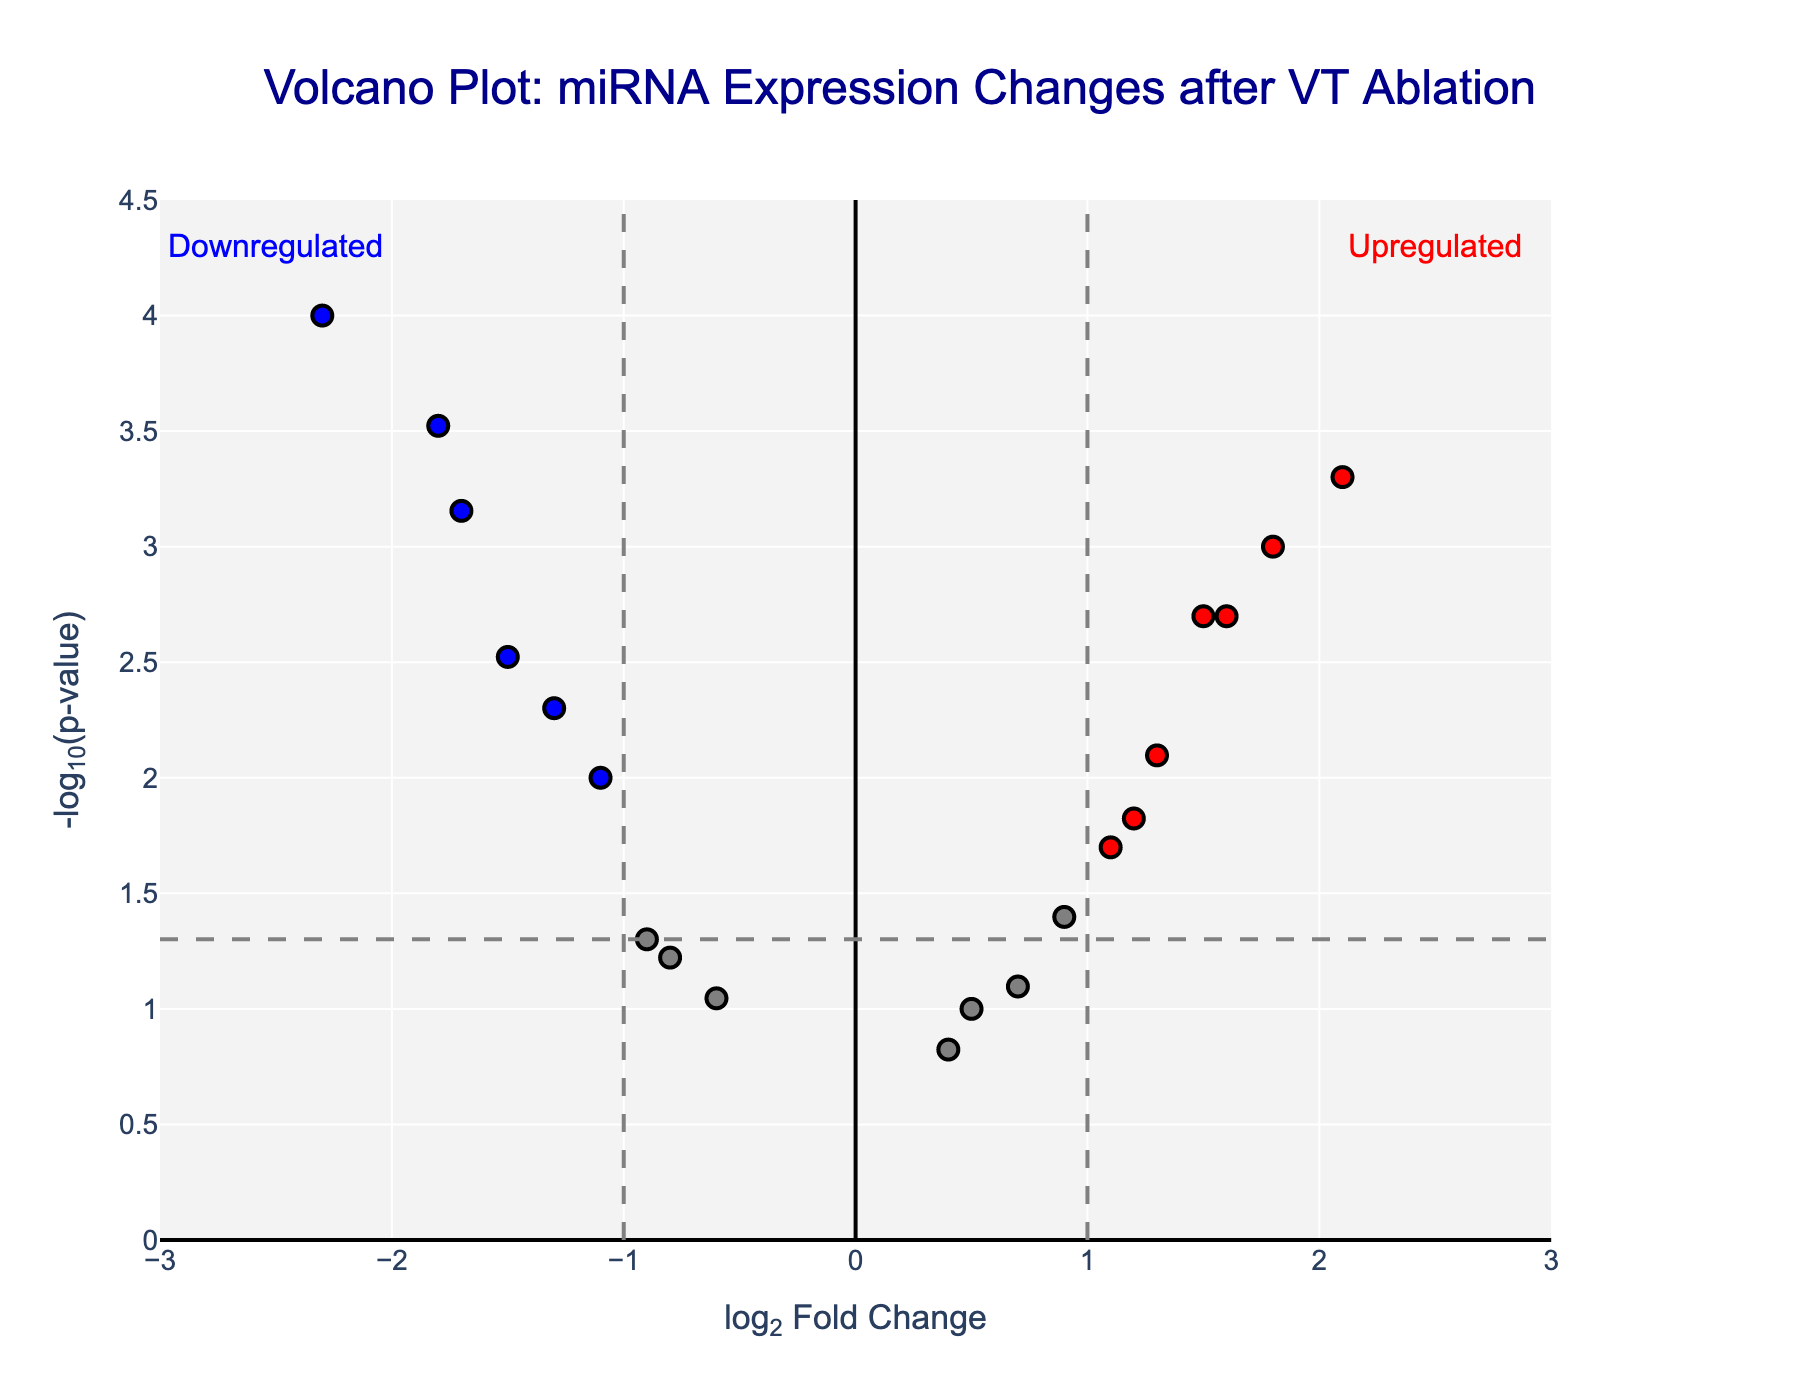Which miRNA has the highest log2 fold change? The highest log2 fold change can be identified by finding the data point furthest to the right of the x-axis. Here, miR-21 has the highest log2 fold change.
Answer: miR-21 Which miRNA has the lowest p-value? The lowest p-value can be identified by finding the data point highest on the y-axis, as p-value is represented on a log scale (-log10). miR-1 has the highest -log10(p-value).
Answer: miR-1 How many miRNAs are significantly upregulated (log2 fold change > 1 and p-value < 0.05)? To count the number of significantly upregulated miRNAs, look for data points that are colored red and are above the horizontal threshold line at -log10(0.05). There are 4 such miRNAs: miR-21, miR-208a, miR-150, and miR-155.
Answer: 4 How many miRNAs are significantly downregulated (log2 fold change < -1 and p-value < 0.05)? To count the number of significantly downregulated miRNAs, look for data points that are colored blue and are above the horizontal threshold line at -log10(0.05). There are 5 such miRNAs: miR-1, miR-133a, miR-195, miR-199a, and miR-486.
Answer: 5 Which miRNA is the closest to the threshold for being considered significantly upregulated? The miRNA closest to the threshold can be identified by finding the red data point that is slightly above the horizontal threshold line (-log10(0.05)) and above the vertical threshold line (log2 fold change > 1). miR-499 is closest to this threshold.
Answer: miR-499 Is there any miRNA with a log2 fold change approximately equal to 0 and a p-value less than 0.05? Inspect the plot for data points that are vertically aligned with log2 fold change around 0 and above the horizontal threshold line at -log10(0.05). There isn't any such miRNA.
Answer: No How many total miRNAs are plotted in the figure? Count all data points visible on the plot. By referring to the initial dataset, there are 19 miRNAs plotted.
Answer: 19 Compare the log2 fold change of miR-423-5p and miR-499, which is higher? Locate the data points for both miR-423-5p and miR-499, compare their positions on the x-axis. miR-423-5p (1.3) has a higher log2 fold change than miR-499 (1.2).
Answer: miR-423-5p What's the average log2 fold change of miR-1 and miR-486? Add the log2 fold changes of miR-1 and miR-486, then divide by 2. (-2.3 + -1.7) / 2 = -2.0
Answer: -2.0 